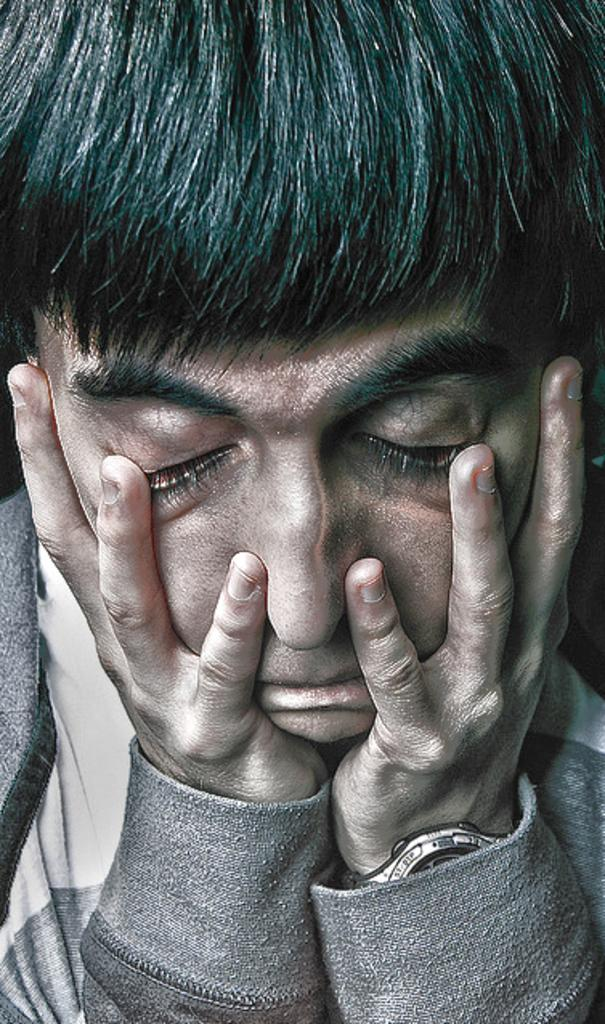What is the main subject of the image? There is a man in the image. What type of glue is the man using in the image? There is no glue present in the image; it only features a man. What school does the man attend in the image? There is no information about the man attending school or any school being present in the image. 